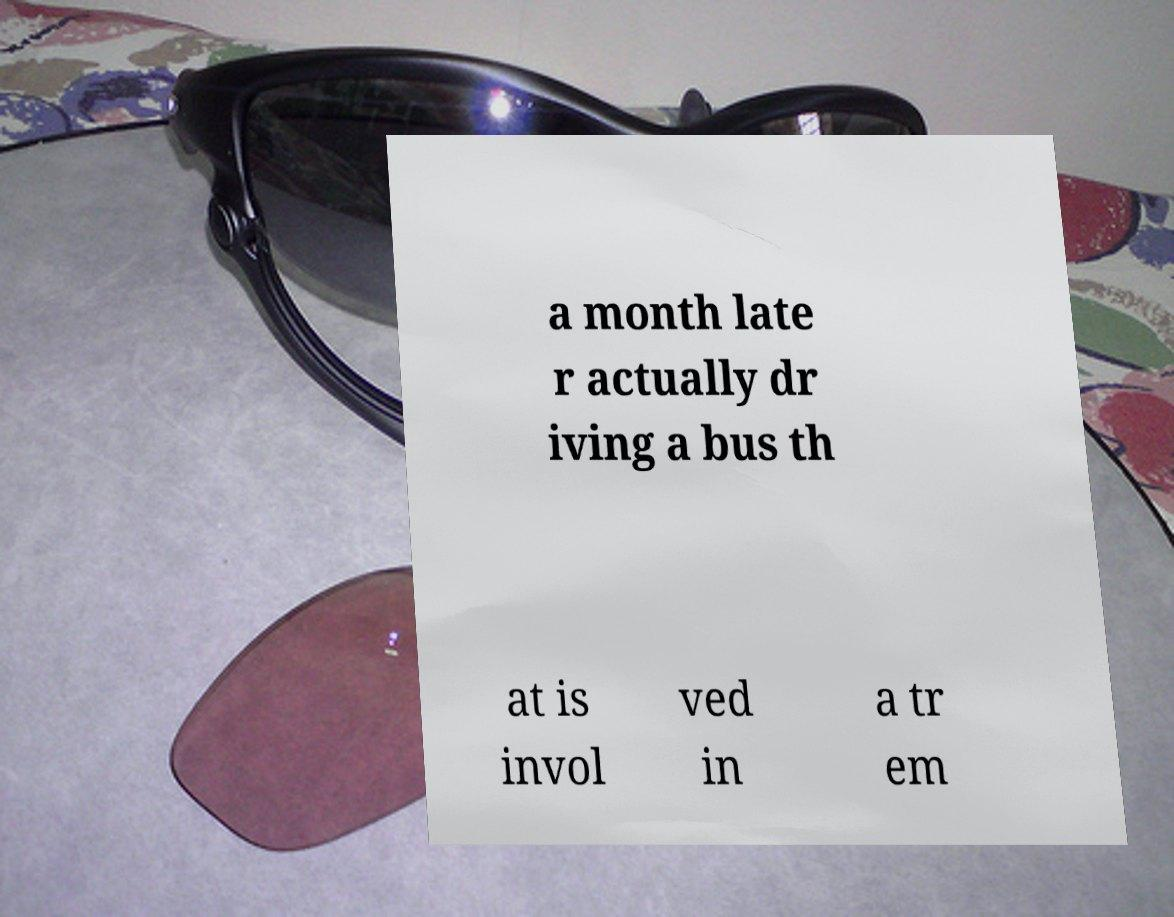What messages or text are displayed in this image? I need them in a readable, typed format. a month late r actually dr iving a bus th at is invol ved in a tr em 